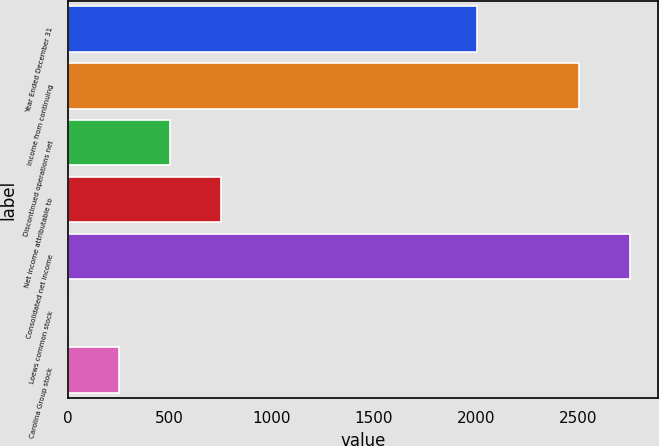Convert chart. <chart><loc_0><loc_0><loc_500><loc_500><bar_chart><fcel>Year Ended December 31<fcel>Income from continuing<fcel>Discontinued operations net<fcel>Net income attributable to<fcel>Consolidated net income<fcel>Loews common stock<fcel>Carolina Group stock<nl><fcel>2006<fcel>2503.44<fcel>501.21<fcel>749.93<fcel>2752.16<fcel>3.75<fcel>252.48<nl></chart> 